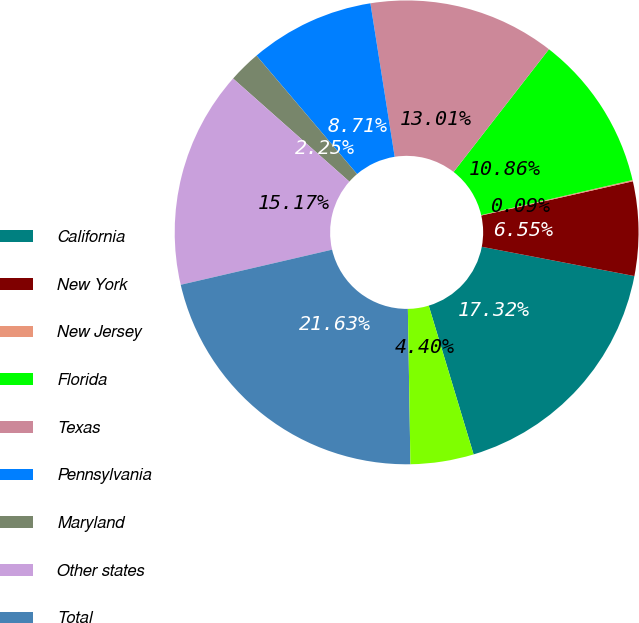<chart> <loc_0><loc_0><loc_500><loc_500><pie_chart><fcel>California<fcel>New York<fcel>New Jersey<fcel>Florida<fcel>Texas<fcel>Pennsylvania<fcel>Maryland<fcel>Other states<fcel>Total<fcel>Ohio<nl><fcel>17.32%<fcel>6.55%<fcel>0.09%<fcel>10.86%<fcel>13.01%<fcel>8.71%<fcel>2.25%<fcel>15.17%<fcel>21.63%<fcel>4.4%<nl></chart> 